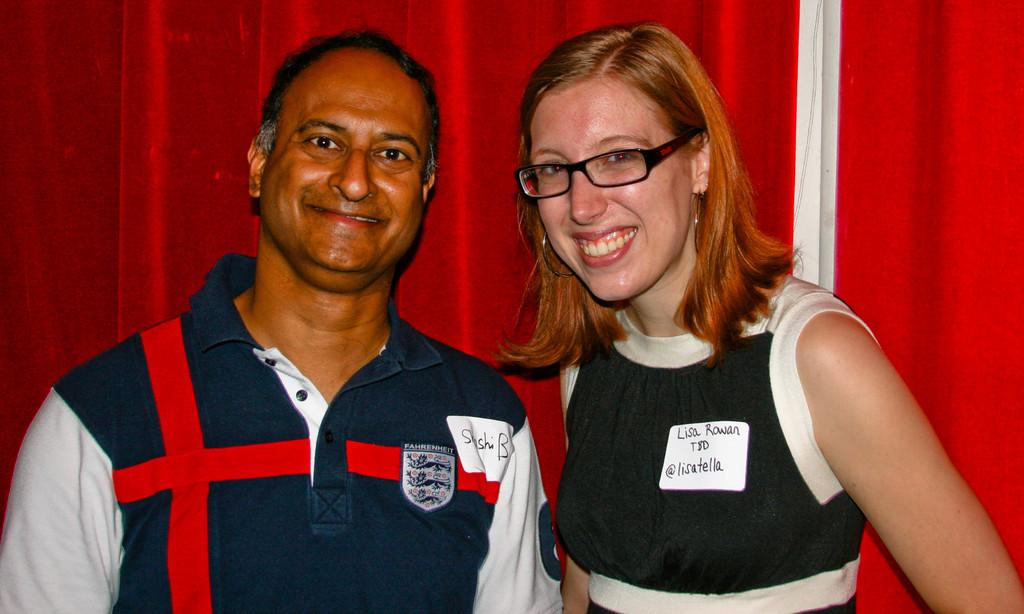Who are the people in the image? There is a man and a woman in the image. What are the expressions on their faces? Both the man and the woman are smiling in the image. What accessory is the woman wearing? The woman is wearing spectacles in the image. What can be seen in the background of the image? There are red color curtains in the background of the image. What type of bed is visible in the image? There is no bed present in the image. How much wealth is displayed in the image? The image does not show any indication of wealth. 